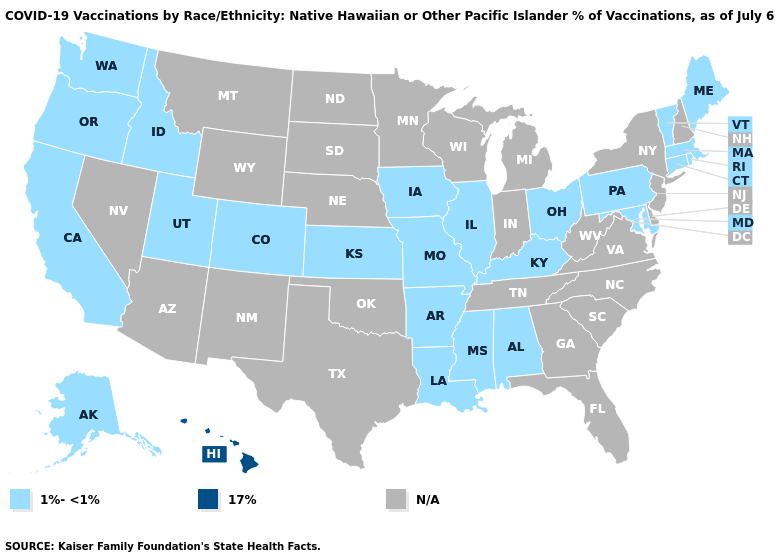Among the states that border Florida , which have the highest value?
Quick response, please. Alabama. Is the legend a continuous bar?
Answer briefly. No. Name the states that have a value in the range N/A?
Write a very short answer. Arizona, Delaware, Florida, Georgia, Indiana, Michigan, Minnesota, Montana, Nebraska, Nevada, New Hampshire, New Jersey, New Mexico, New York, North Carolina, North Dakota, Oklahoma, South Carolina, South Dakota, Tennessee, Texas, Virginia, West Virginia, Wisconsin, Wyoming. Name the states that have a value in the range N/A?
Give a very brief answer. Arizona, Delaware, Florida, Georgia, Indiana, Michigan, Minnesota, Montana, Nebraska, Nevada, New Hampshire, New Jersey, New Mexico, New York, North Carolina, North Dakota, Oklahoma, South Carolina, South Dakota, Tennessee, Texas, Virginia, West Virginia, Wisconsin, Wyoming. Which states have the lowest value in the USA?
Short answer required. Alabama, Alaska, Arkansas, California, Colorado, Connecticut, Idaho, Illinois, Iowa, Kansas, Kentucky, Louisiana, Maine, Maryland, Massachusetts, Mississippi, Missouri, Ohio, Oregon, Pennsylvania, Rhode Island, Utah, Vermont, Washington. What is the value of Mississippi?
Write a very short answer. 1%-<1%. Does Hawaii have the lowest value in the West?
Quick response, please. No. What is the value of New Jersey?
Answer briefly. N/A. What is the value of Washington?
Keep it brief. 1%-<1%. What is the value of Mississippi?
Short answer required. 1%-<1%. Name the states that have a value in the range 1%-<1%?
Answer briefly. Alabama, Alaska, Arkansas, California, Colorado, Connecticut, Idaho, Illinois, Iowa, Kansas, Kentucky, Louisiana, Maine, Maryland, Massachusetts, Mississippi, Missouri, Ohio, Oregon, Pennsylvania, Rhode Island, Utah, Vermont, Washington. 